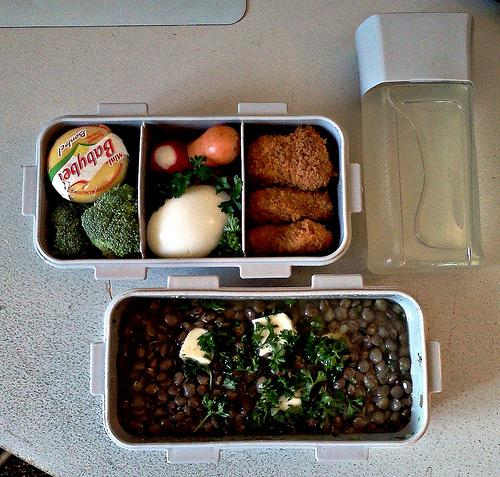Question: where is the beans?
Choices:
A. A pot.
B. Tupperware.
C. A mug.
D. A tray.
Answer with the letter. Answer: D Question: what is on the beans?
Choices:
A. Tortillas.
B. Veggies.
C. Sauce.
D. Olives.
Answer with the letter. Answer: B Question: where was the photo taken?
Choices:
A. On a sofa.
B. On a table top.
C. On a bannister.
D. On a mantle.
Answer with the letter. Answer: B Question: what color is the table?
Choices:
A. Black.
B. Yellow.
C. White.
D. Brown.
Answer with the letter. Answer: C Question: how many things on the table?
Choices:
A. Four.
B. Three.
C. Two.
D. Six.
Answer with the letter. Answer: B Question: what is in the bottle?
Choices:
A. Water.
B. Juice.
C. Soda.
D. Beer.
Answer with the letter. Answer: A Question: when was the photo taken?
Choices:
A. Noon.
B. Evening.
C. Supper time.
D. Lunch time.
Answer with the letter. Answer: D 